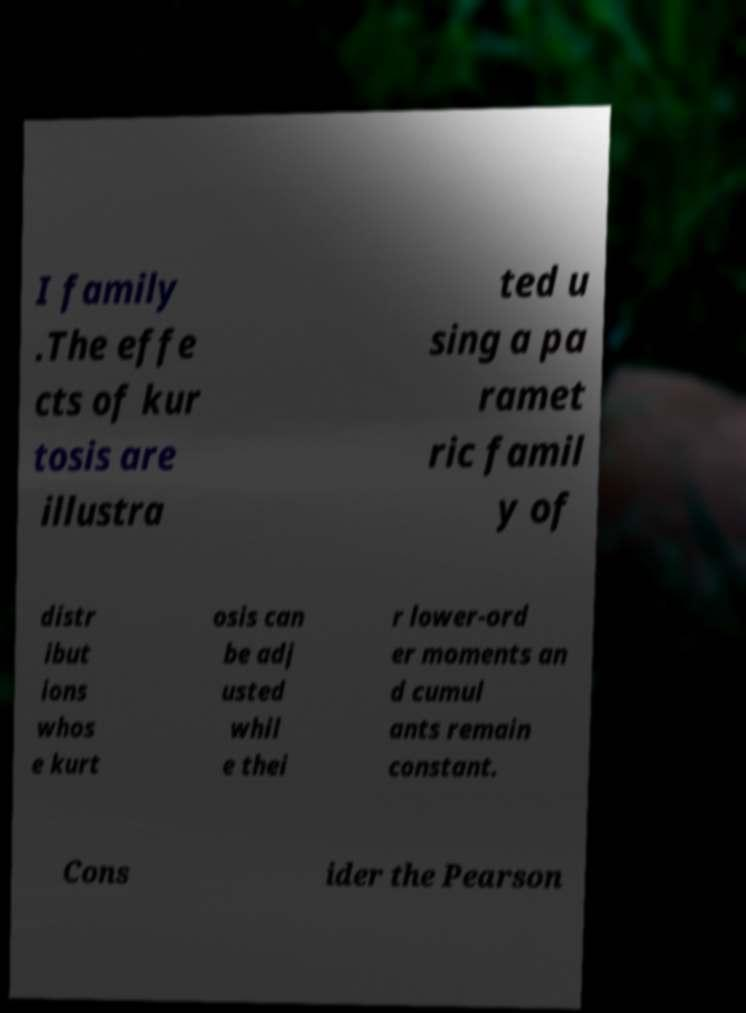There's text embedded in this image that I need extracted. Can you transcribe it verbatim? I family .The effe cts of kur tosis are illustra ted u sing a pa ramet ric famil y of distr ibut ions whos e kurt osis can be adj usted whil e thei r lower-ord er moments an d cumul ants remain constant. Cons ider the Pearson 